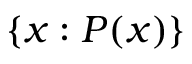<formula> <loc_0><loc_0><loc_500><loc_500>\{ x \colon P ( x ) \}</formula> 